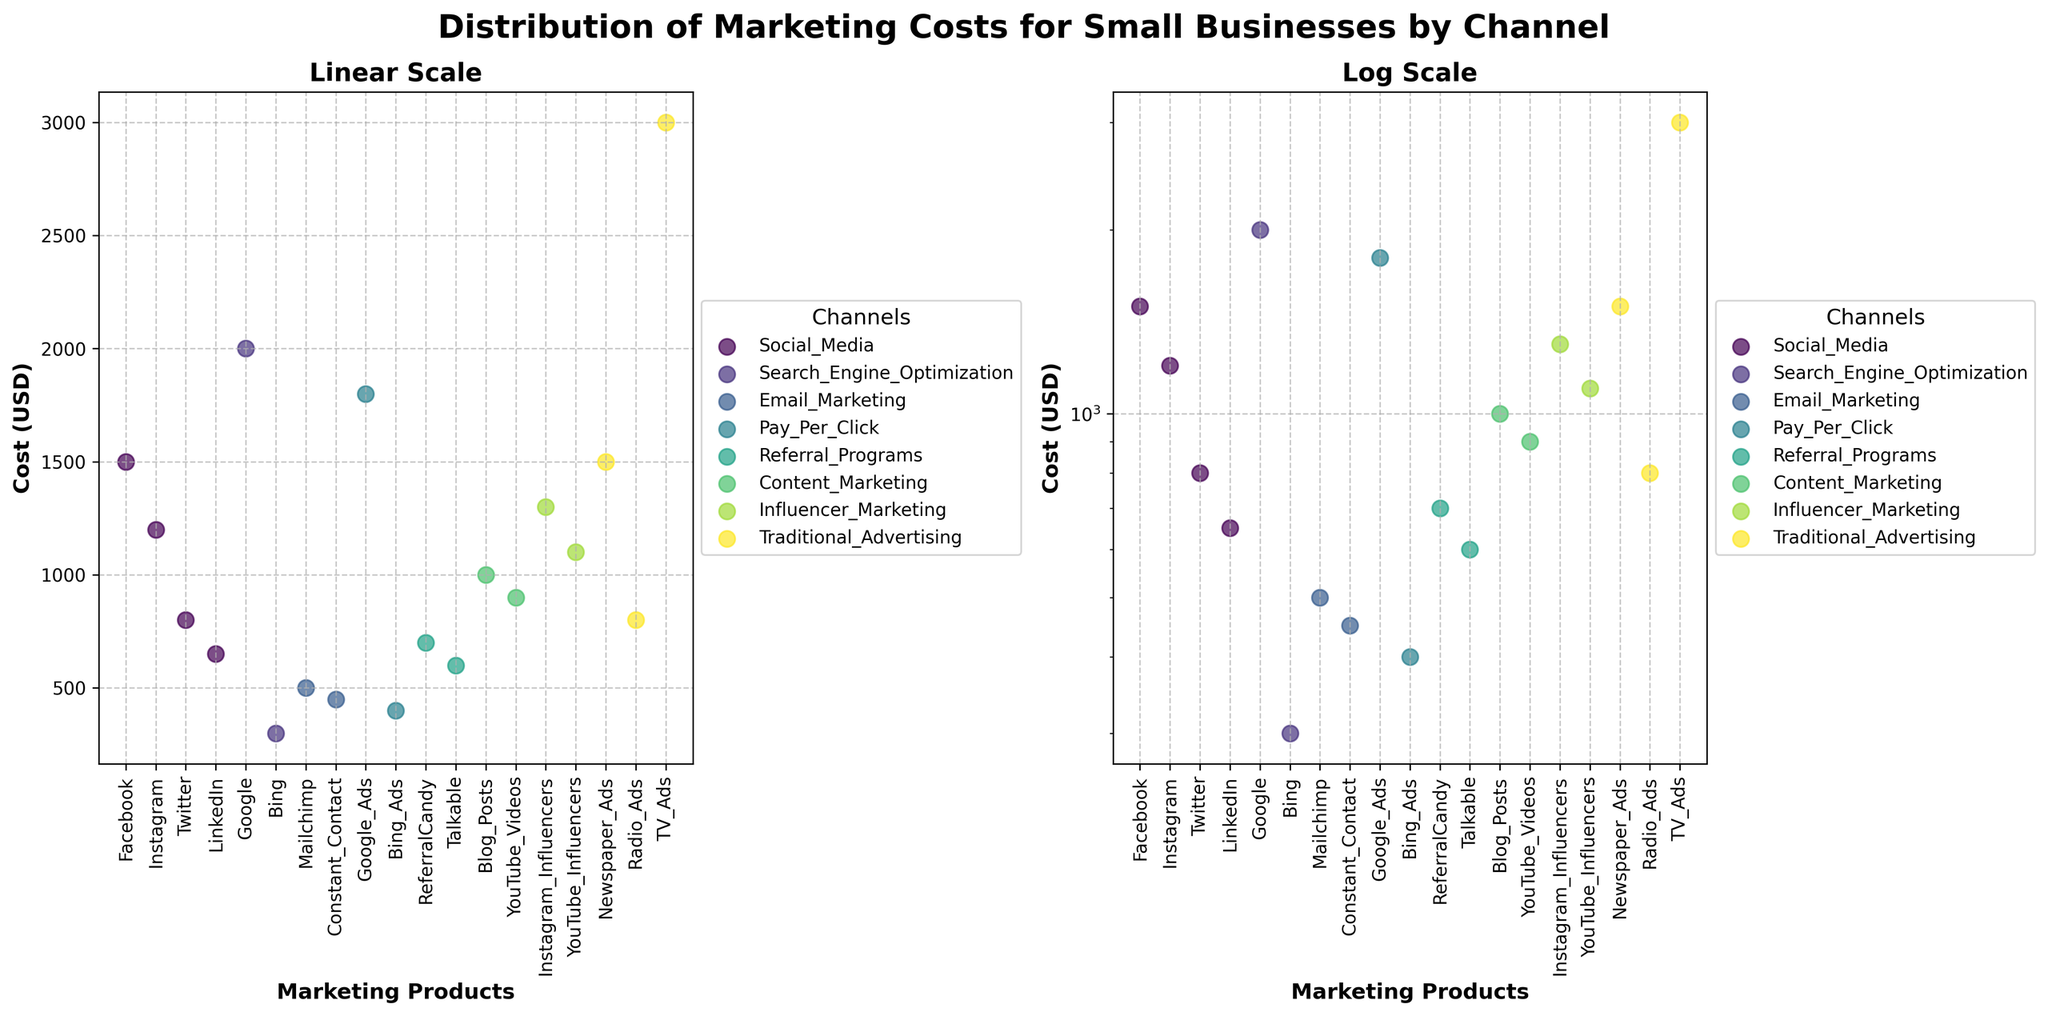Which marketing channel has the highest cost for small businesses in the log scale subplot? In the log scale subplot, look for the highest point on the y-axis. TV Ads under Traditional Advertising is at the top with a cost of $3000.
Answer: Traditional Advertising (TV Ads) What's the title of the figure? The title is displayed at the top of the figure, usually in a larger and bold font to capture attention. The title is "Distribution of Marketing Costs for Small Businesses by Channel".
Answer: Distribution of Marketing Costs for Small Businesses by Channel How do the email marketing costs for Mailchimp and Constant Contact compare on the log scale? Look for the points representing Mailchimp and Constant Contact in the log scale subplot. Mailchimp has a cost of $500, while Constant Contact has a cost of $450. Mailchimp is slightly higher.
Answer: Mailchimp is higher Which product has the lowest cost according to the log scale subplot? In the log scale subplot, find the point at the lowest position on the y-axis. Bing under Search Engine Optimization has the lowest cost at $300.
Answer: Bing (Search Engine Optimization) Are the costs for Google Ads higher or lower than those for Facebook on both subplots? Locate Google Ads and Facebook in both subplots. Google Ads costs $1800 and Facebook costs $1500. In both subplots (linear and log scale), Google Ads has a higher cost than Facebook.
Answer: Google Ads is higher What is the average cost of influencer marketing on the linear scale? On the linear scale subplot, locate and sum the costs of Instagram Influencers ($1300) and YouTube Influencers ($1100) and then divide by the number of products (2). The sum is $2400, and the average is $2400/2 = $1200.
Answer: $1200 Which channel has the most data points in the figure? Identify the number of points each channel has. Social Media has 4 points (Facebook, Instagram, Twitter, LinkedIn), which is the highest among all channels.
Answer: Social Media Between Traditional Advertising and Content Marketing, which has a higher maximum cost observed? Compare the highest points of each channel in the subplots. Traditional Advertising has a maximum cost of $3000 (TV Ads), whereas Content Marketing has a maximum cost of $1000 (Blog Posts).
Answer: Traditional Advertising Are the marketing costs generally higher for Search Engine Optimization or Referral Programs? Compare the y-axis positions of the points for Search Engine Optimization (Google: $2000, Bing: $300) and Referral Programs (ReferralCandy: $700, Talkable: $600). Search Engine Optimization has higher costs overall due to Google's $2000 cost.
Answer: Search Engine Optimization Which marketing channel shows more variability in costs (range) according to the linear scale subplot? Look at the spread of points for each channel on the linear scale. Traditional Advertising ranges from $800 (Radio Ads) to $3000 (TV Ads). This channel shows the highest variability (range of $2200).
Answer: Traditional Advertising 